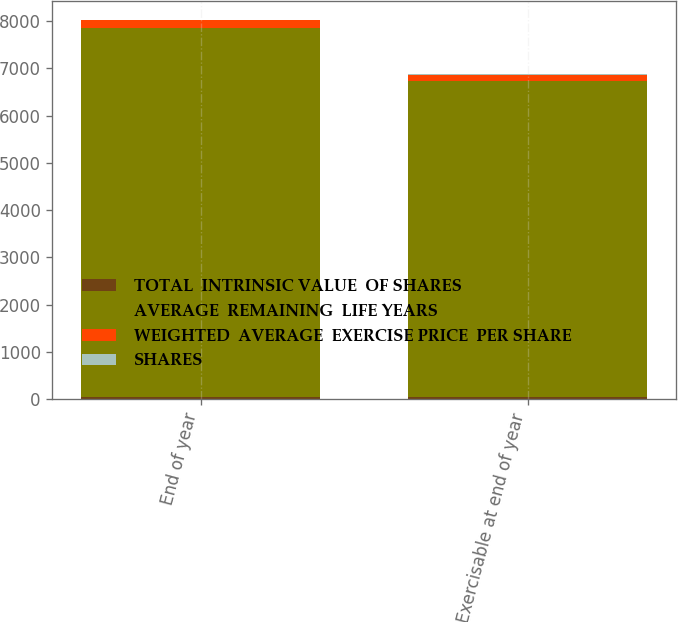Convert chart. <chart><loc_0><loc_0><loc_500><loc_500><stacked_bar_chart><ecel><fcel>End of year<fcel>Exercisable at end of year<nl><fcel>TOTAL  INTRINSIC VALUE  OF SHARES<fcel>56.37<fcel>57.3<nl><fcel>AVERAGE  REMAINING  LIFE YEARS<fcel>7801<fcel>6680<nl><fcel>WEIGHTED  AVERAGE  EXERCISE PRICE  PER SHARE<fcel>160<fcel>131<nl><fcel>SHARES<fcel>5.1<fcel>4.8<nl></chart> 